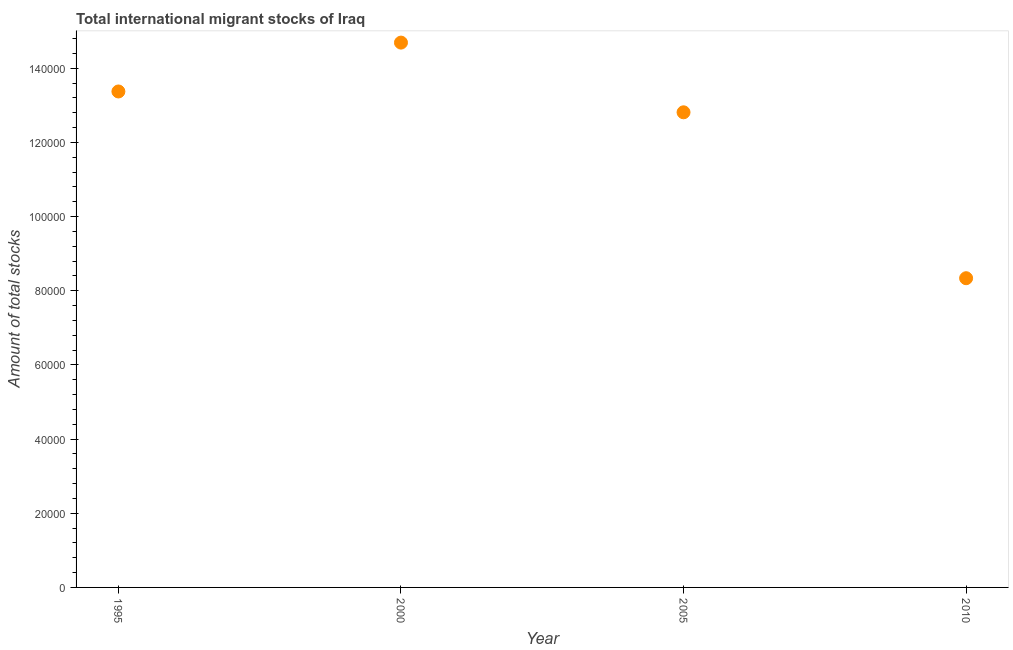What is the total number of international migrant stock in 2000?
Make the answer very short. 1.47e+05. Across all years, what is the maximum total number of international migrant stock?
Provide a short and direct response. 1.47e+05. Across all years, what is the minimum total number of international migrant stock?
Keep it short and to the point. 8.34e+04. In which year was the total number of international migrant stock maximum?
Provide a short and direct response. 2000. What is the sum of the total number of international migrant stock?
Provide a succinct answer. 4.92e+05. What is the difference between the total number of international migrant stock in 1995 and 2010?
Make the answer very short. 5.04e+04. What is the average total number of international migrant stock per year?
Give a very brief answer. 1.23e+05. What is the median total number of international migrant stock?
Your response must be concise. 1.31e+05. In how many years, is the total number of international migrant stock greater than 136000 ?
Provide a short and direct response. 1. What is the ratio of the total number of international migrant stock in 1995 to that in 2005?
Give a very brief answer. 1.04. What is the difference between the highest and the second highest total number of international migrant stock?
Ensure brevity in your answer.  1.32e+04. Is the sum of the total number of international migrant stock in 1995 and 2010 greater than the maximum total number of international migrant stock across all years?
Offer a terse response. Yes. What is the difference between the highest and the lowest total number of international migrant stock?
Your answer should be very brief. 6.35e+04. In how many years, is the total number of international migrant stock greater than the average total number of international migrant stock taken over all years?
Offer a very short reply. 3. How many years are there in the graph?
Give a very brief answer. 4. What is the title of the graph?
Your answer should be very brief. Total international migrant stocks of Iraq. What is the label or title of the X-axis?
Your answer should be compact. Year. What is the label or title of the Y-axis?
Your answer should be very brief. Amount of total stocks. What is the Amount of total stocks in 1995?
Your answer should be compact. 1.34e+05. What is the Amount of total stocks in 2000?
Provide a short and direct response. 1.47e+05. What is the Amount of total stocks in 2005?
Offer a terse response. 1.28e+05. What is the Amount of total stocks in 2010?
Ensure brevity in your answer.  8.34e+04. What is the difference between the Amount of total stocks in 1995 and 2000?
Give a very brief answer. -1.32e+04. What is the difference between the Amount of total stocks in 1995 and 2005?
Your response must be concise. 5618. What is the difference between the Amount of total stocks in 1995 and 2010?
Offer a very short reply. 5.04e+04. What is the difference between the Amount of total stocks in 2000 and 2005?
Provide a short and direct response. 1.88e+04. What is the difference between the Amount of total stocks in 2000 and 2010?
Offer a very short reply. 6.35e+04. What is the difference between the Amount of total stocks in 2005 and 2010?
Ensure brevity in your answer.  4.47e+04. What is the ratio of the Amount of total stocks in 1995 to that in 2000?
Offer a very short reply. 0.91. What is the ratio of the Amount of total stocks in 1995 to that in 2005?
Keep it short and to the point. 1.04. What is the ratio of the Amount of total stocks in 1995 to that in 2010?
Offer a very short reply. 1.6. What is the ratio of the Amount of total stocks in 2000 to that in 2005?
Provide a succinct answer. 1.15. What is the ratio of the Amount of total stocks in 2000 to that in 2010?
Your answer should be compact. 1.76. What is the ratio of the Amount of total stocks in 2005 to that in 2010?
Keep it short and to the point. 1.54. 